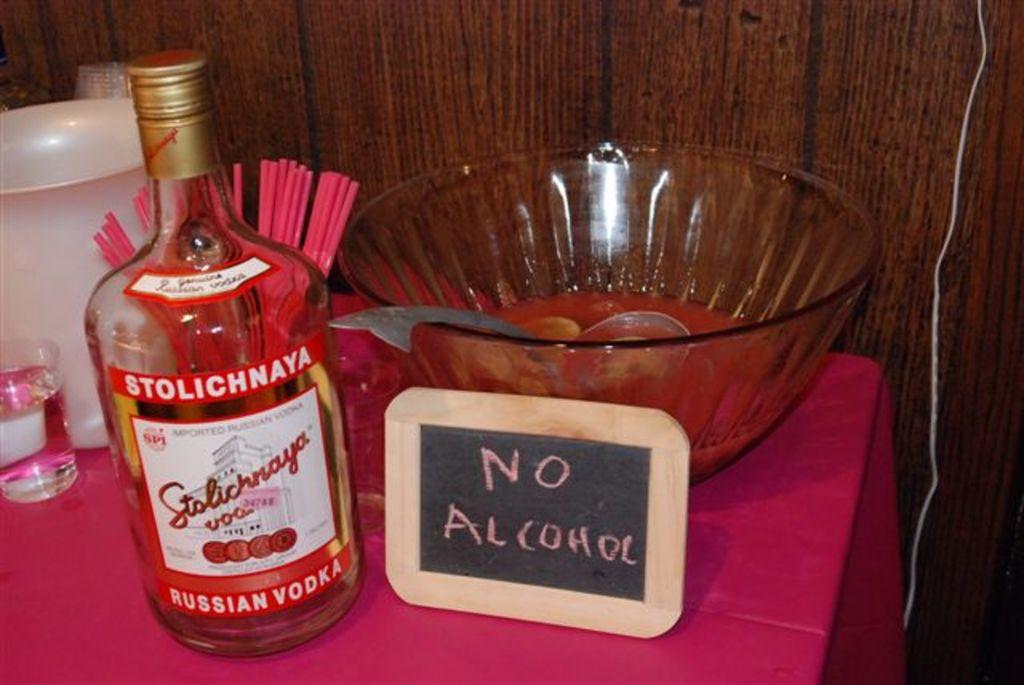What type of alcohol is shown in this picture?
Offer a terse response. Vodka. What does the sign say?
Your answer should be compact. No alcohol. 